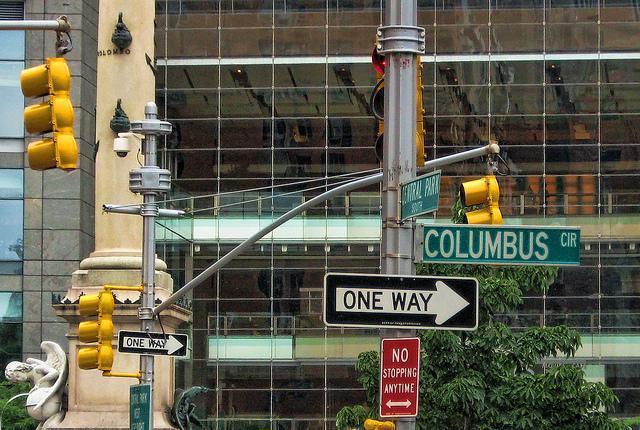How many signs are in this scene?
Give a very brief answer. 6. How many ways is Columbus Cir?
Give a very brief answer. 1. How many traffic lights are visible?
Give a very brief answer. 2. 